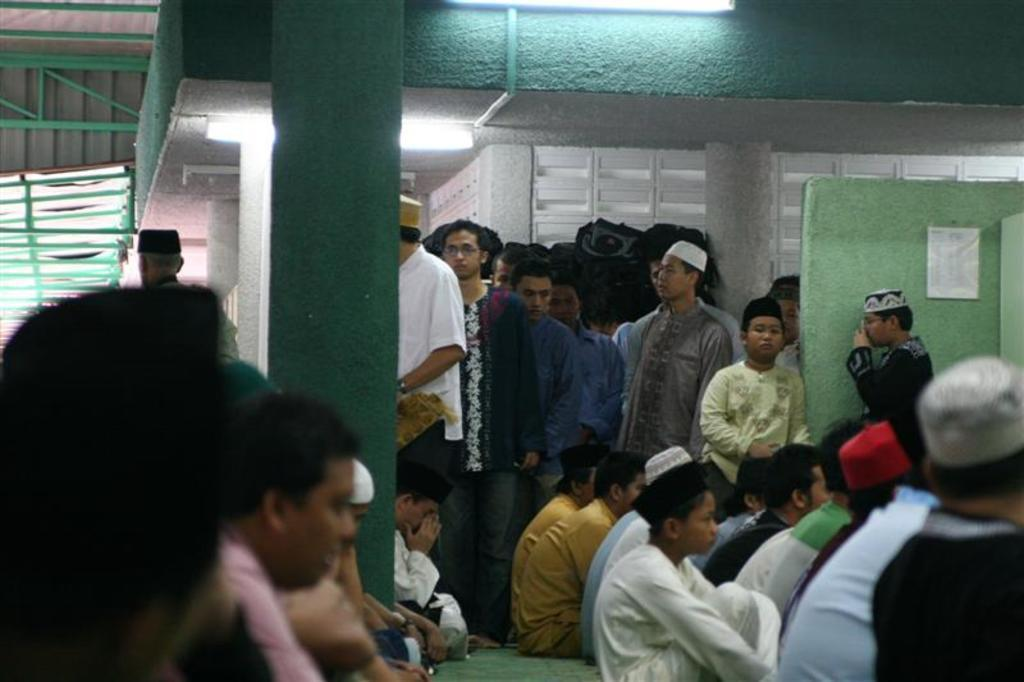What are the people in the foreground of the image doing? The people sitting on the floor at the bottom of the image are likely engaged in an activity or conversation. What can be seen in the background of the image? There are people standing in the background of the image. What architectural feature is visible in the image? There is a wall visible in the image. What other structural elements can be seen in the image? There are pillars in the image. What type of apparel is the wall wearing in the image? Walls do not wear apparel; they are inanimate objects. How many times does the roll occur in the image? There is no rolling or repetitive action depicted in the image. 